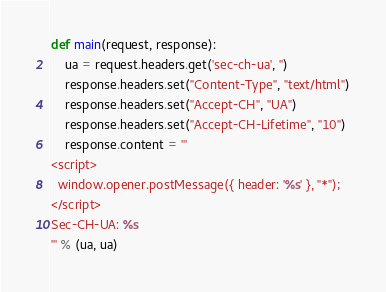Convert code to text. <code><loc_0><loc_0><loc_500><loc_500><_Python_>def main(request, response):
    ua = request.headers.get('sec-ch-ua', '')
    response.headers.set("Content-Type", "text/html")
    response.headers.set("Accept-CH", "UA")
    response.headers.set("Accept-CH-Lifetime", "10")
    response.content = '''
<script>
  window.opener.postMessage({ header: '%s' }, "*");
</script>
Sec-CH-UA: %s
''' % (ua, ua)
</code> 